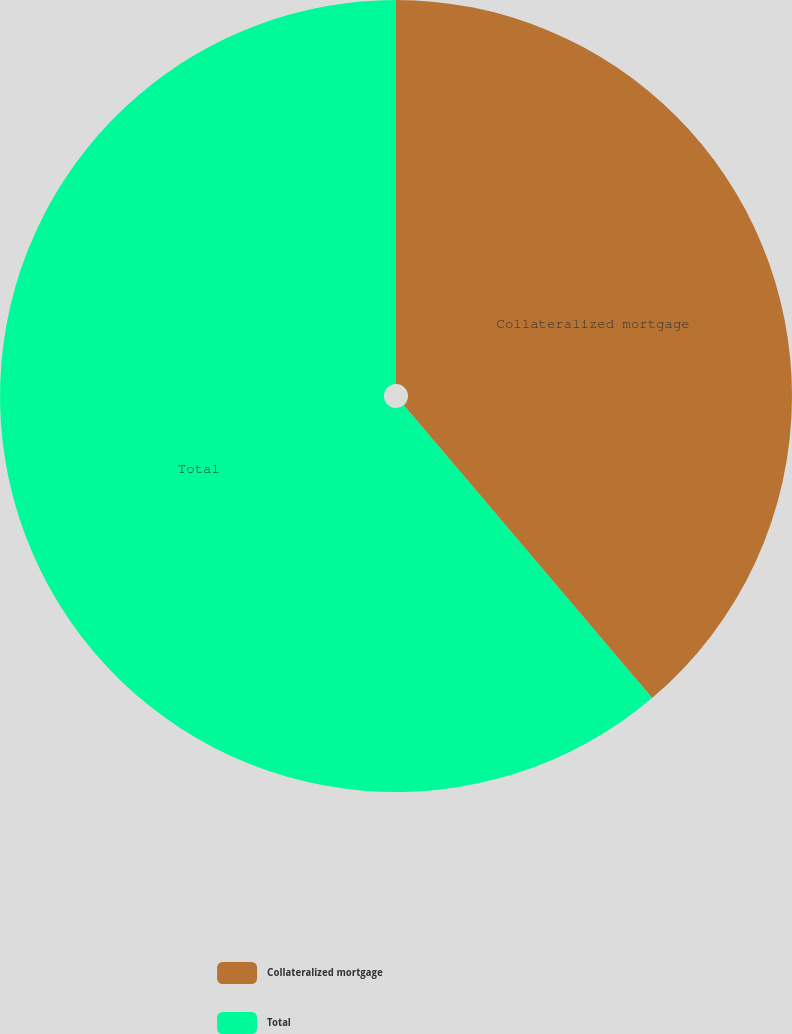<chart> <loc_0><loc_0><loc_500><loc_500><pie_chart><fcel>Collateralized mortgage<fcel>Total<nl><fcel>38.81%<fcel>61.19%<nl></chart> 